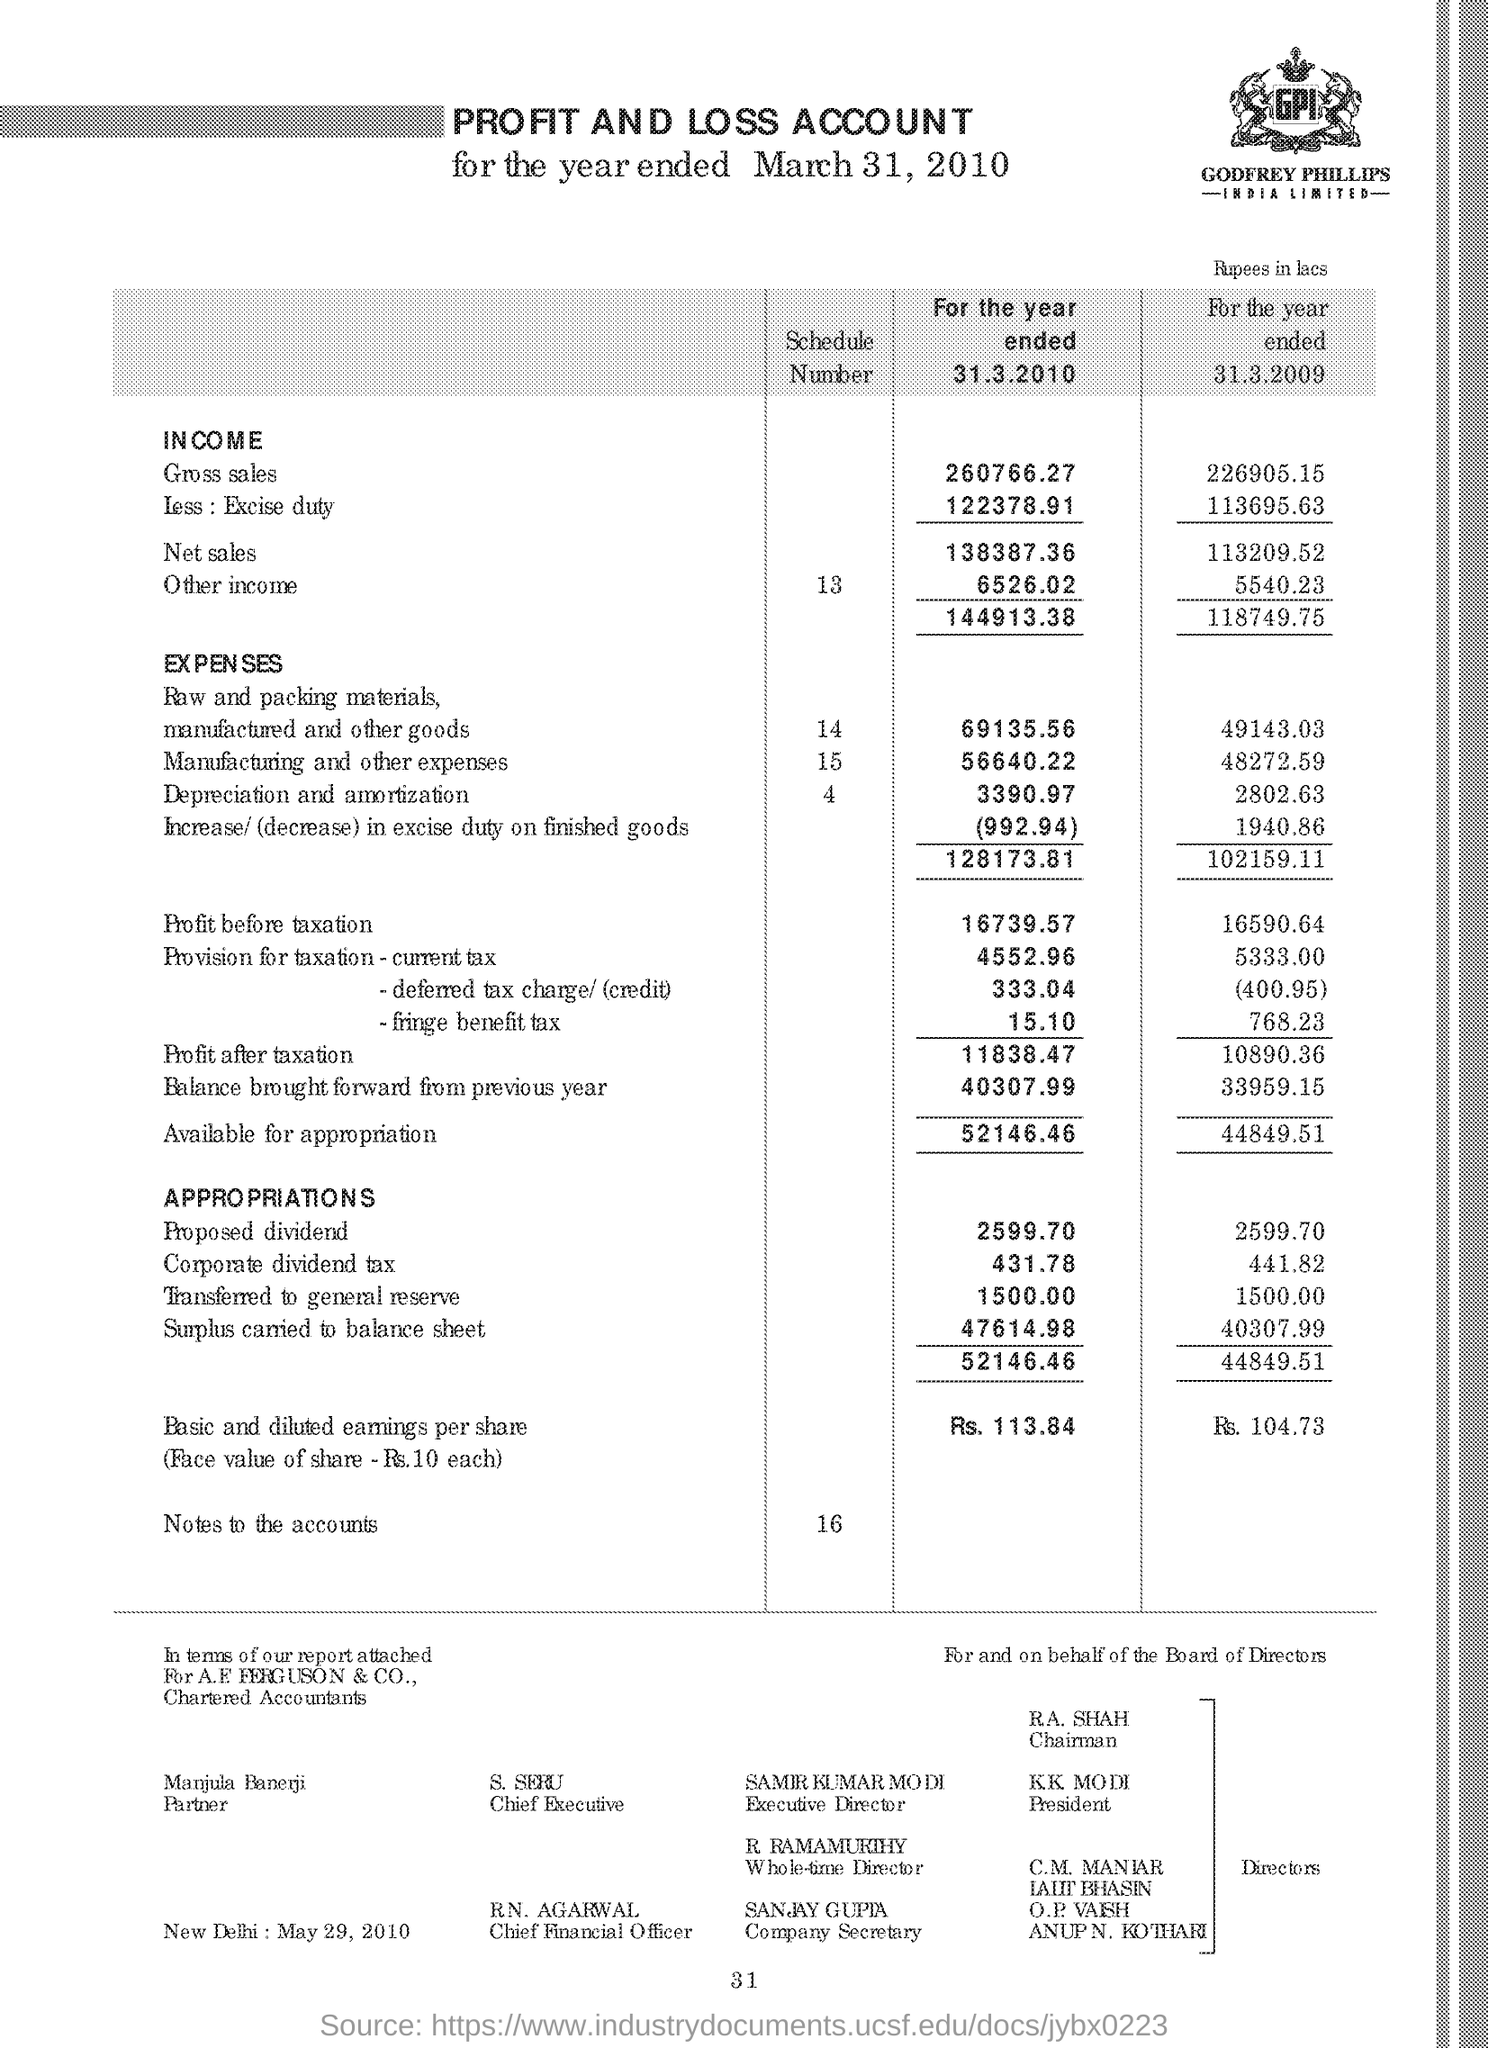What is the income of the gross sales for the year ended 31.3.2010
Provide a short and direct response. 260766.27. What is the income of the gross sales for the year ended 31.3.2009
Ensure brevity in your answer.  226905.15. Who is the executive director ?
Provide a short and direct response. Samir kumar modi. Who is the company secretary ?
Give a very brief answer. Sanjay gupta. 